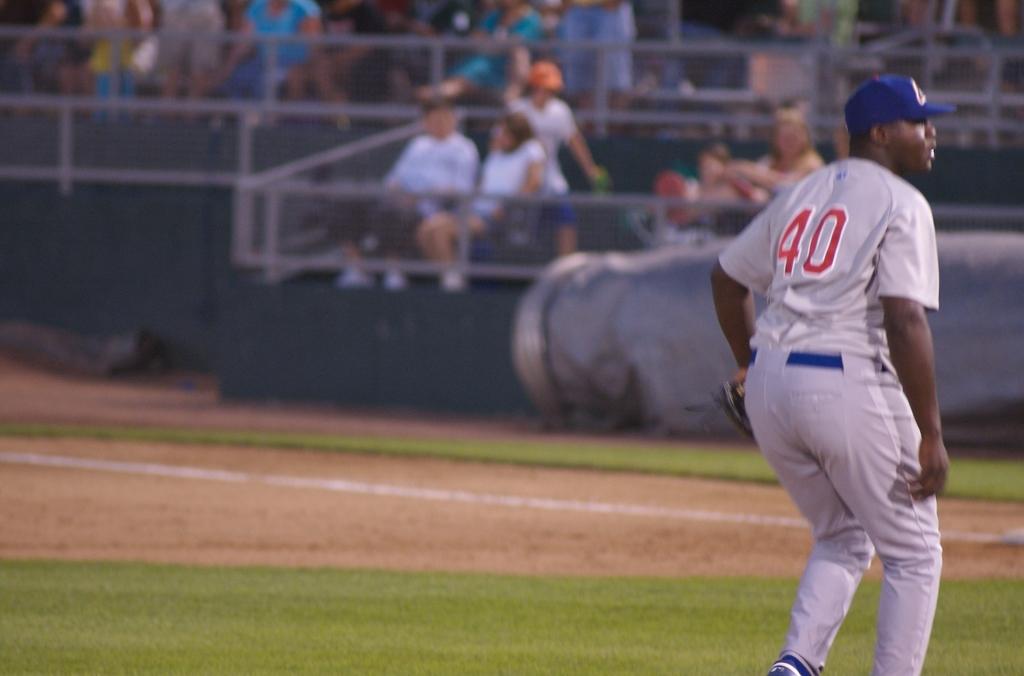What number is on the jersey?
Provide a succinct answer. 40. 